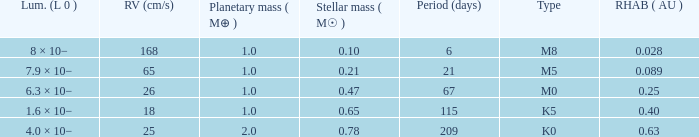Can you give me this table as a dict? {'header': ['Lum. (L 0 )', 'RV (cm/s)', 'Planetary mass ( M⊕ )', 'Stellar mass ( M☉ )', 'Period (days)', 'Type', 'RHAB ( AU )'], 'rows': [['8 × 10−', '168', '1.0', '0.10', '6', 'M8', '0.028'], ['7.9 × 10−', '65', '1.0', '0.21', '21', 'M5', '0.089'], ['6.3 × 10−', '26', '1.0', '0.47', '67', 'M0', '0.25'], ['1.6 × 10−', '18', '1.0', '0.65', '115', 'K5', '0.40'], ['4.0 × 10−', '25', '2.0', '0.78', '209', 'K0', '0.63']]} What is the total stellar mass of the type m0? 0.47. 